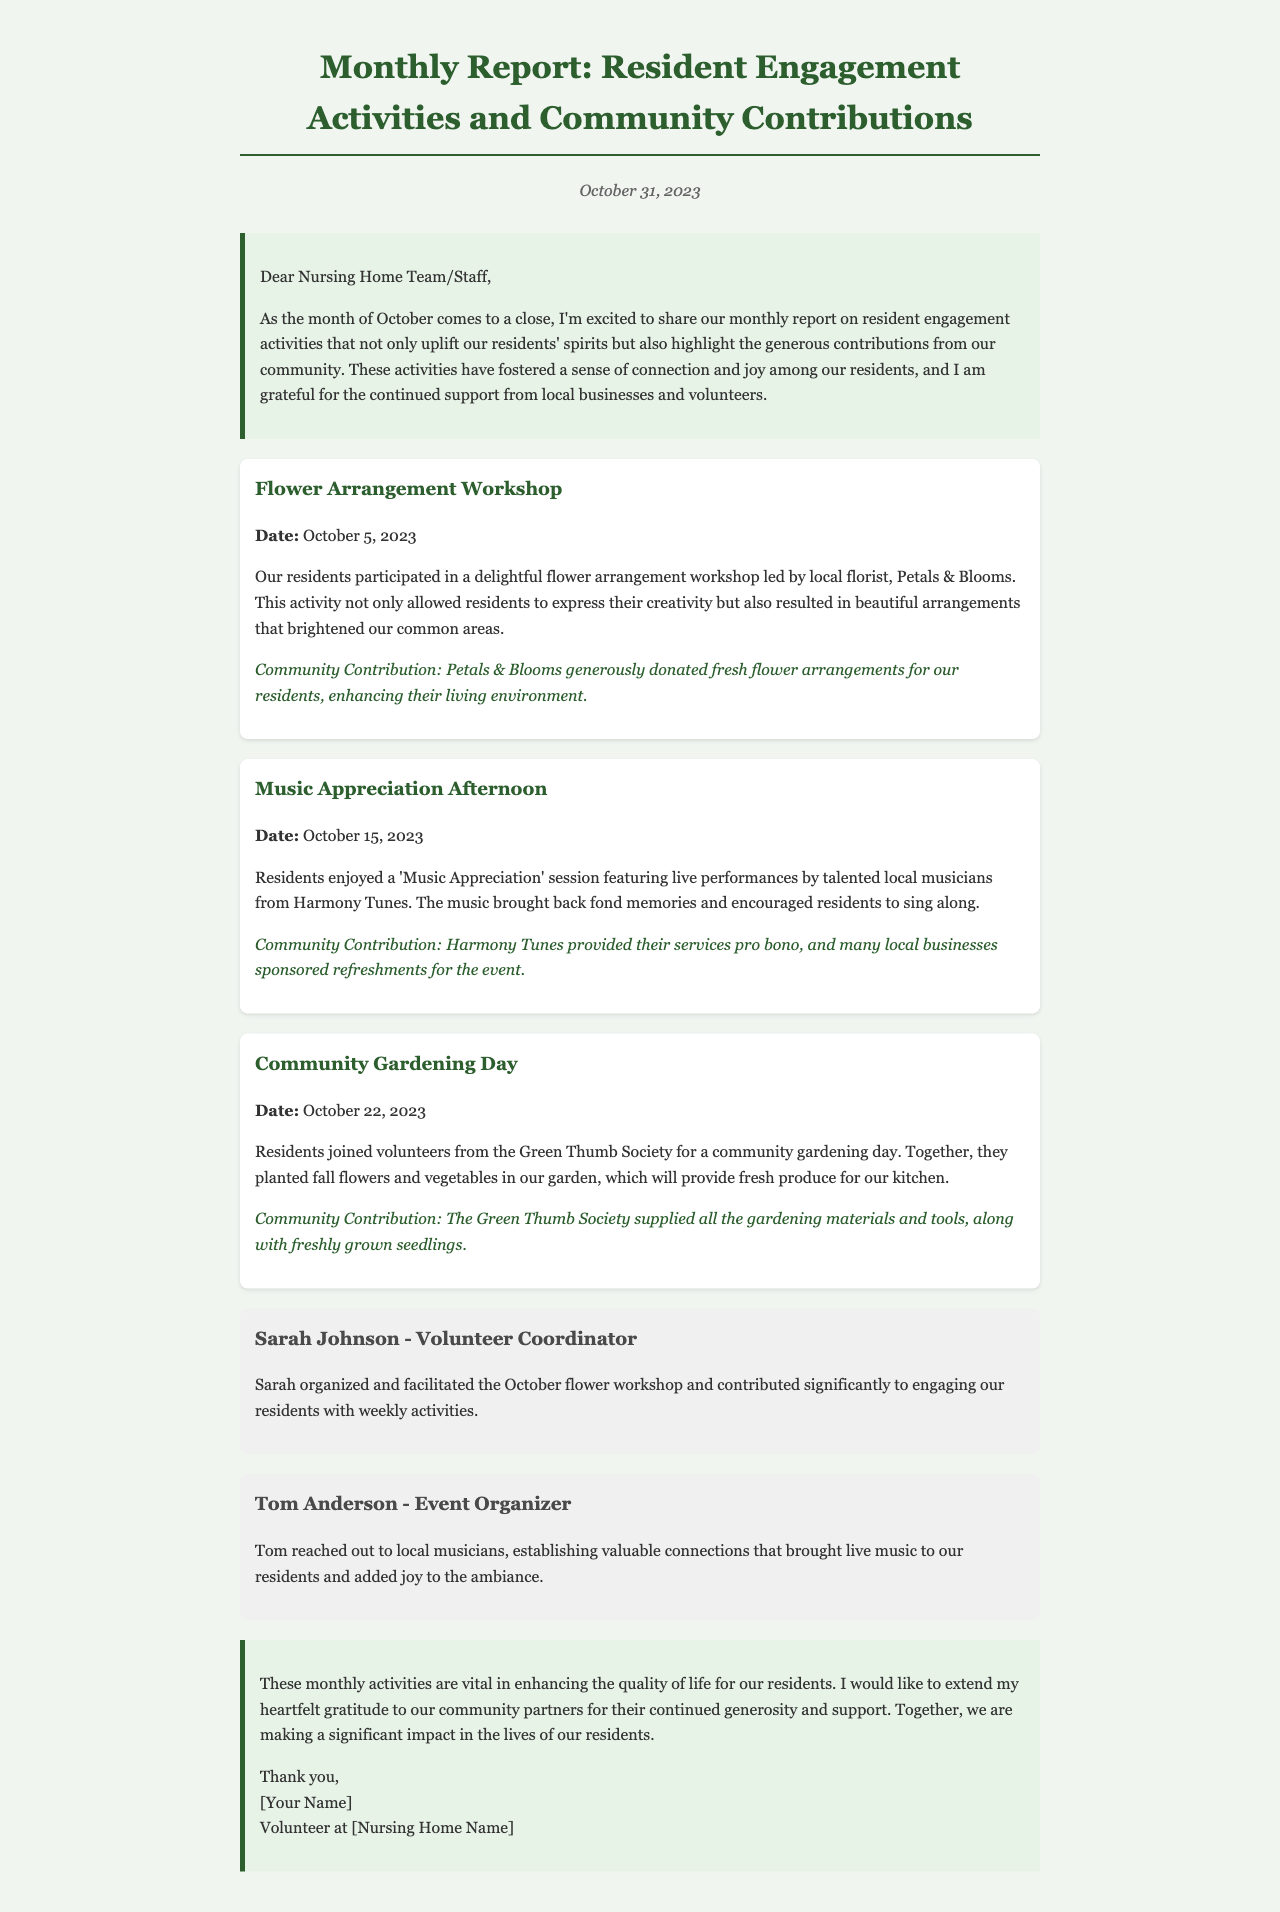What was the date of the Flower Arrangement Workshop? The date of the Flower Arrangement Workshop is explicitly mentioned in the document under the respective activity section.
Answer: October 5, 2023 Who organized the Flower Arrangement Workshop? The document states that Sarah Johnson was responsible for organizing and facilitating the October flower workshop.
Answer: Sarah Johnson Which local business donated fresh flower arrangements? The document specifies that Petals & Blooms generously donated fresh flower arrangements for the residents.
Answer: Petals & Blooms What activity took place on October 15, 2023? This date is provided in the document along with its associated activity, allowing us to directly answer the question.
Answer: Music Appreciation Afternoon How many volunteers are mentioned in the report? The document lists two volunteers along with their contributions, which allows us to find the answer.
Answer: 2 What type of contributions did Harmony Tunes provide? The document explains that Harmony Tunes provided their services pro bono for the music event.
Answer: Pro bono Who coordinated the activities for the month of October? The document identifies Sarah Johnson as the volunteer coordinator who facilitated the flower workshop and engaged residents.
Answer: Sarah Johnson What was planted during the Community Gardening Day? The report clearly mentions that fall flowers and vegetables were planted in the garden.
Answer: Fall flowers and vegetables 